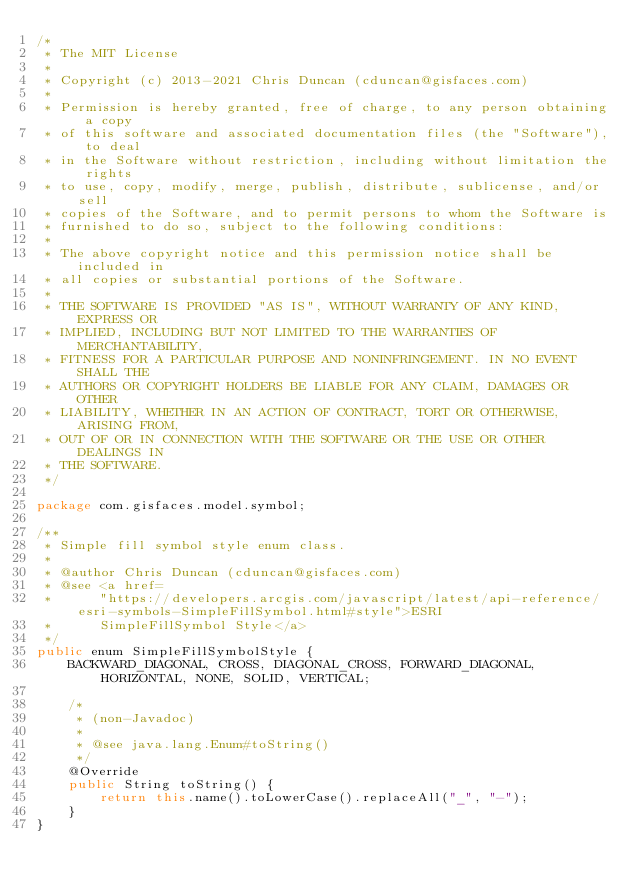<code> <loc_0><loc_0><loc_500><loc_500><_Java_>/*
 * The MIT License
 *
 * Copyright (c) 2013-2021 Chris Duncan (cduncan@gisfaces.com)
 *
 * Permission is hereby granted, free of charge, to any person obtaining a copy
 * of this software and associated documentation files (the "Software"), to deal
 * in the Software without restriction, including without limitation the rights
 * to use, copy, modify, merge, publish, distribute, sublicense, and/or sell
 * copies of the Software, and to permit persons to whom the Software is
 * furnished to do so, subject to the following conditions:
 *
 * The above copyright notice and this permission notice shall be included in
 * all copies or substantial portions of the Software.
 *
 * THE SOFTWARE IS PROVIDED "AS IS", WITHOUT WARRANTY OF ANY KIND, EXPRESS OR
 * IMPLIED, INCLUDING BUT NOT LIMITED TO THE WARRANTIES OF MERCHANTABILITY,
 * FITNESS FOR A PARTICULAR PURPOSE AND NONINFRINGEMENT. IN NO EVENT SHALL THE
 * AUTHORS OR COPYRIGHT HOLDERS BE LIABLE FOR ANY CLAIM, DAMAGES OR OTHER
 * LIABILITY, WHETHER IN AN ACTION OF CONTRACT, TORT OR OTHERWISE, ARISING FROM,
 * OUT OF OR IN CONNECTION WITH THE SOFTWARE OR THE USE OR OTHER DEALINGS IN
 * THE SOFTWARE.
 */

package com.gisfaces.model.symbol;

/**
 * Simple fill symbol style enum class.
 * 
 * @author Chris Duncan (cduncan@gisfaces.com)
 * @see <a href=
 *      "https://developers.arcgis.com/javascript/latest/api-reference/esri-symbols-SimpleFillSymbol.html#style">ESRI
 *      SimpleFillSymbol Style</a>
 */
public enum SimpleFillSymbolStyle {
	BACKWARD_DIAGONAL, CROSS, DIAGONAL_CROSS, FORWARD_DIAGONAL, HORIZONTAL, NONE, SOLID, VERTICAL;

	/*
	 * (non-Javadoc)
	 * 
	 * @see java.lang.Enum#toString()
	 */
	@Override
	public String toString() {
		return this.name().toLowerCase().replaceAll("_", "-");
	}
}
</code> 